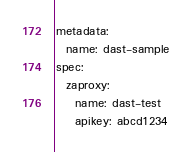<code> <loc_0><loc_0><loc_500><loc_500><_YAML_>metadata:
  name: dast-sample
spec:
  zaproxy:
    name: dast-test
    apikey: abcd1234
</code> 